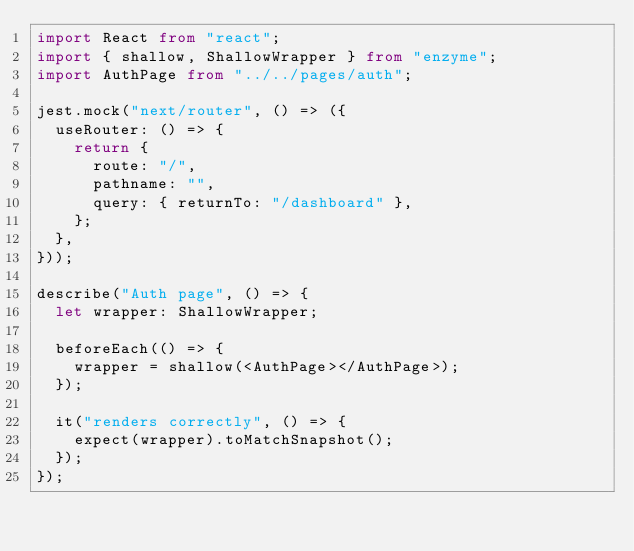Convert code to text. <code><loc_0><loc_0><loc_500><loc_500><_TypeScript_>import React from "react";
import { shallow, ShallowWrapper } from "enzyme";
import AuthPage from "../../pages/auth";

jest.mock("next/router", () => ({
  useRouter: () => {
    return {
      route: "/",
      pathname: "",
      query: { returnTo: "/dashboard" },
    };
  },
}));

describe("Auth page", () => {
  let wrapper: ShallowWrapper;

  beforeEach(() => {
    wrapper = shallow(<AuthPage></AuthPage>);
  });

  it("renders correctly", () => {
    expect(wrapper).toMatchSnapshot();
  });
});
</code> 